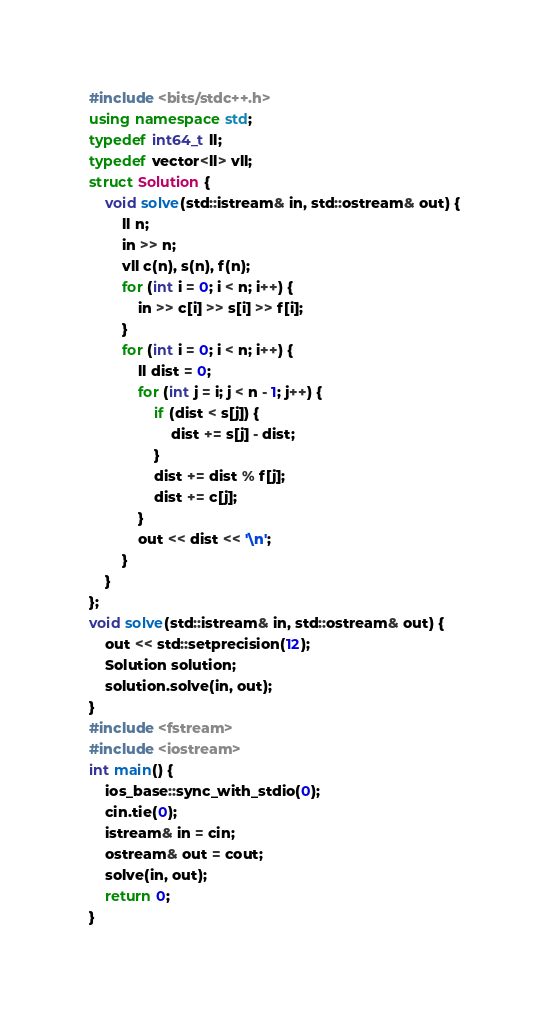<code> <loc_0><loc_0><loc_500><loc_500><_C++_>#include <bits/stdc++.h>
using namespace std;
typedef int64_t ll;
typedef vector<ll> vll;
struct Solution {
    void solve(std::istream& in, std::ostream& out) {
        ll n;
        in >> n;
        vll c(n), s(n), f(n);
        for (int i = 0; i < n; i++) {
            in >> c[i] >> s[i] >> f[i];
        }
        for (int i = 0; i < n; i++) {
            ll dist = 0;
            for (int j = i; j < n - 1; j++) {
                if (dist < s[j]) {
                    dist += s[j] - dist;
                }
                dist += dist % f[j];
                dist += c[j];
            }
            out << dist << '\n';
        }
    }
};
void solve(std::istream& in, std::ostream& out) {
    out << std::setprecision(12);
    Solution solution;
    solution.solve(in, out);
}
#include <fstream>
#include <iostream>
int main() {
    ios_base::sync_with_stdio(0);
    cin.tie(0);
    istream& in = cin;
    ostream& out = cout;
    solve(in, out);
    return 0;
}
</code> 